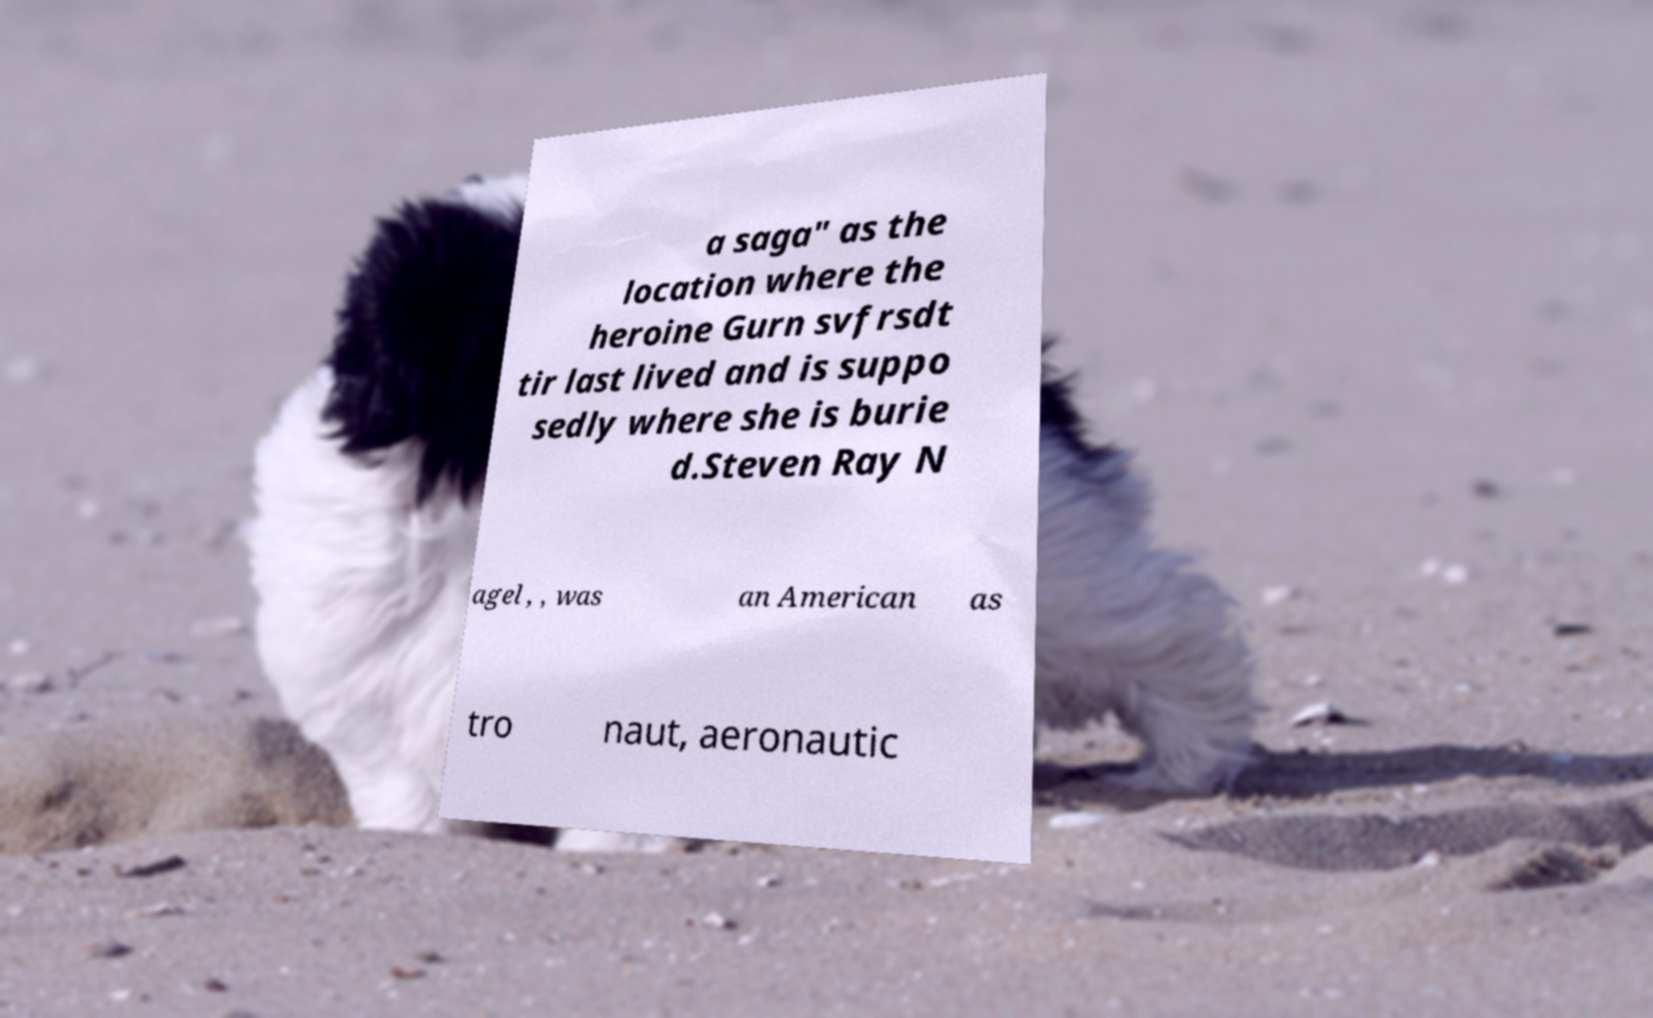Could you assist in decoding the text presented in this image and type it out clearly? a saga" as the location where the heroine Gurn svfrsdt tir last lived and is suppo sedly where she is burie d.Steven Ray N agel , , was an American as tro naut, aeronautic 